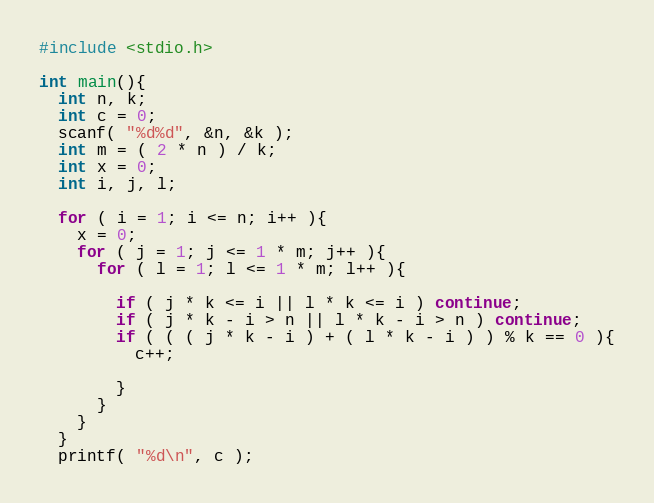<code> <loc_0><loc_0><loc_500><loc_500><_C_>#include <stdio.h>

int main(){
  int n, k;
  int c = 0;
  scanf( "%d%d", &n, &k );
  int m = ( 2 * n ) / k;
  int x = 0;
  int i, j, l;
  
  for ( i = 1; i <= n; i++ ){
    x = 0;
    for ( j = 1; j <= 1 * m; j++ ){
      for ( l = 1; l <= 1 * m; l++ ){

        if ( j * k <= i || l * k <= i ) continue;
        if ( j * k - i > n || l * k - i > n ) continue;
        if ( ( ( j * k - i ) + ( l * k - i ) ) % k == 0 ){
          c++;

        }
      }
    }
  }
  printf( "%d\n", c );</code> 